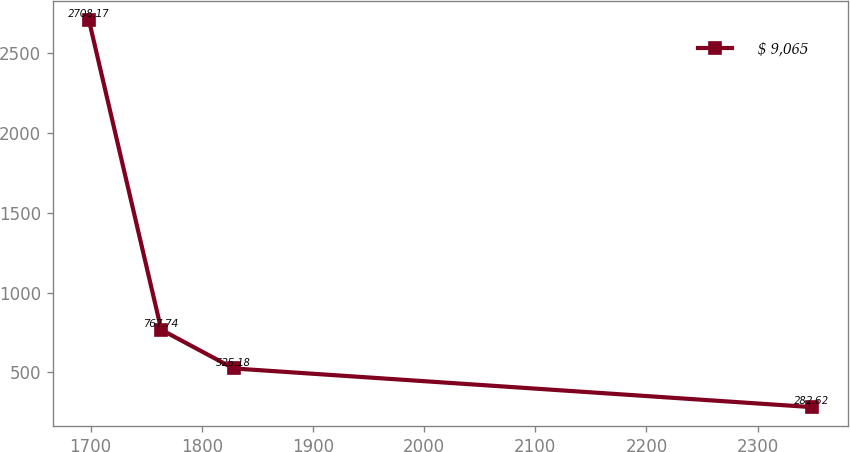<chart> <loc_0><loc_0><loc_500><loc_500><line_chart><ecel><fcel>$ 9,065<nl><fcel>1698.48<fcel>2708.17<nl><fcel>1763.54<fcel>767.74<nl><fcel>1828.6<fcel>525.18<nl><fcel>2349.09<fcel>282.62<nl></chart> 